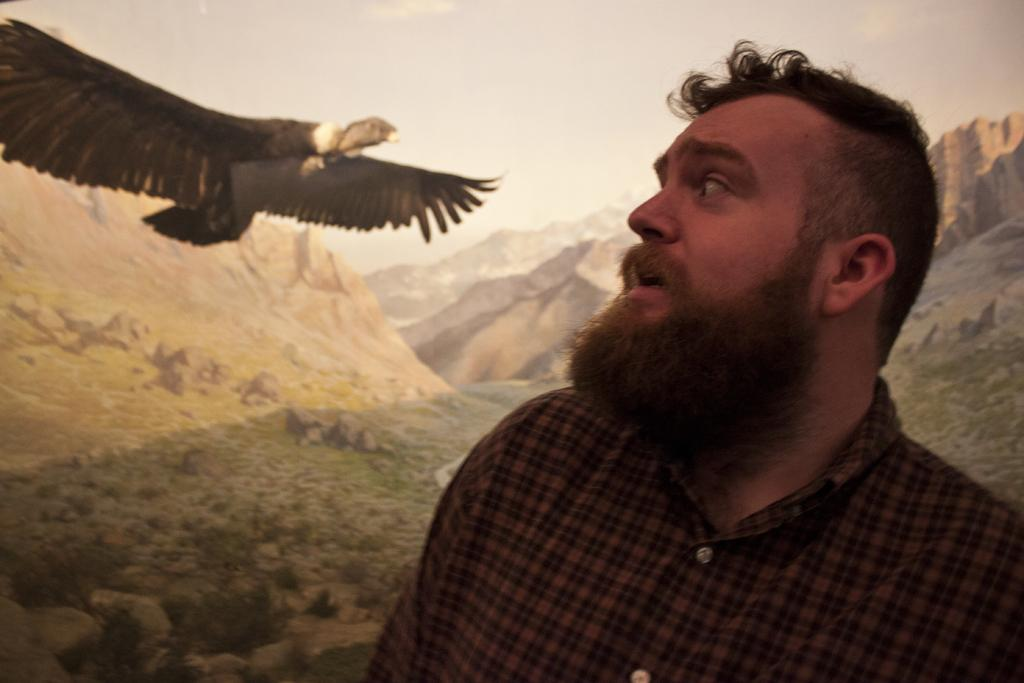What is located on the right side of the image? There is a man on the right side of the image. What is on the left side of the image? There is an eagle on the left side of the image. What type of environment is visible in the background of the image? There is grassland in the background of the image. What type of tray is the man holding in the image? There is no tray present in the image; the man is not holding anything. 